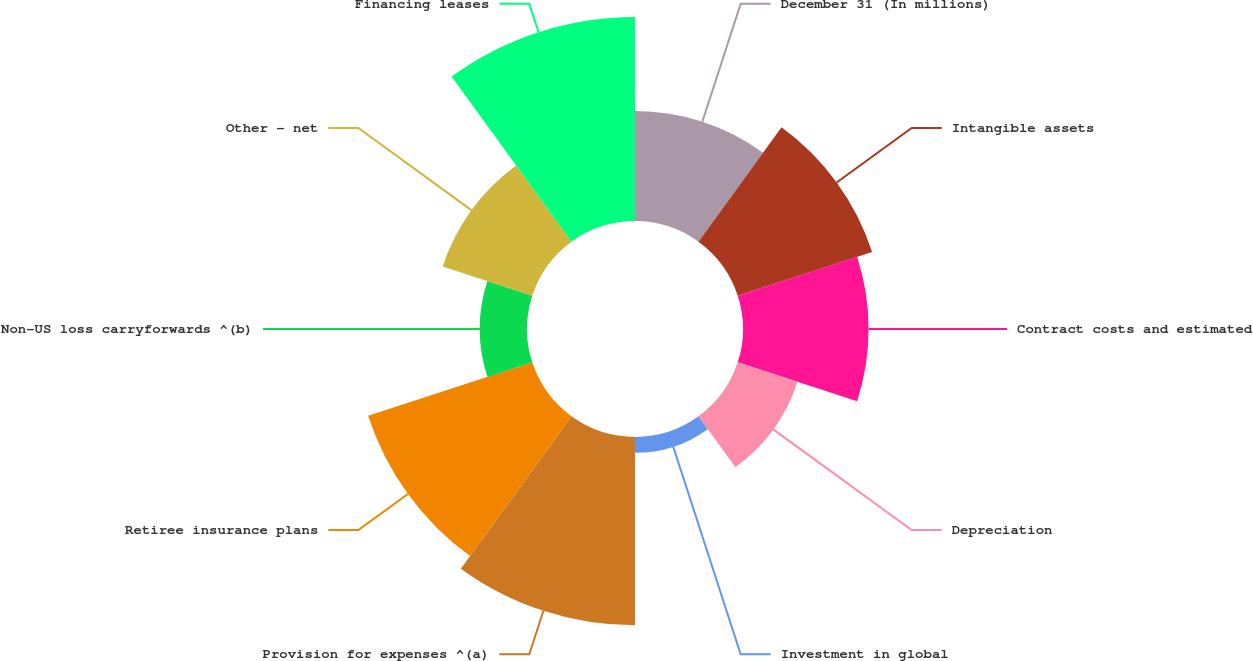<chart> <loc_0><loc_0><loc_500><loc_500><pie_chart><fcel>December 31 (In millions)<fcel>Intangible assets<fcel>Contract costs and estimated<fcel>Depreciation<fcel>Investment in global<fcel>Provision for expenses ^(a)<fcel>Retiree insurance plans<fcel>Non-US loss carryforwards ^(b)<fcel>Other - net<fcel>Financing leases<nl><fcel>9.46%<fcel>12.16%<fcel>10.81%<fcel>5.41%<fcel>1.36%<fcel>16.21%<fcel>14.86%<fcel>4.06%<fcel>8.11%<fcel>17.56%<nl></chart> 